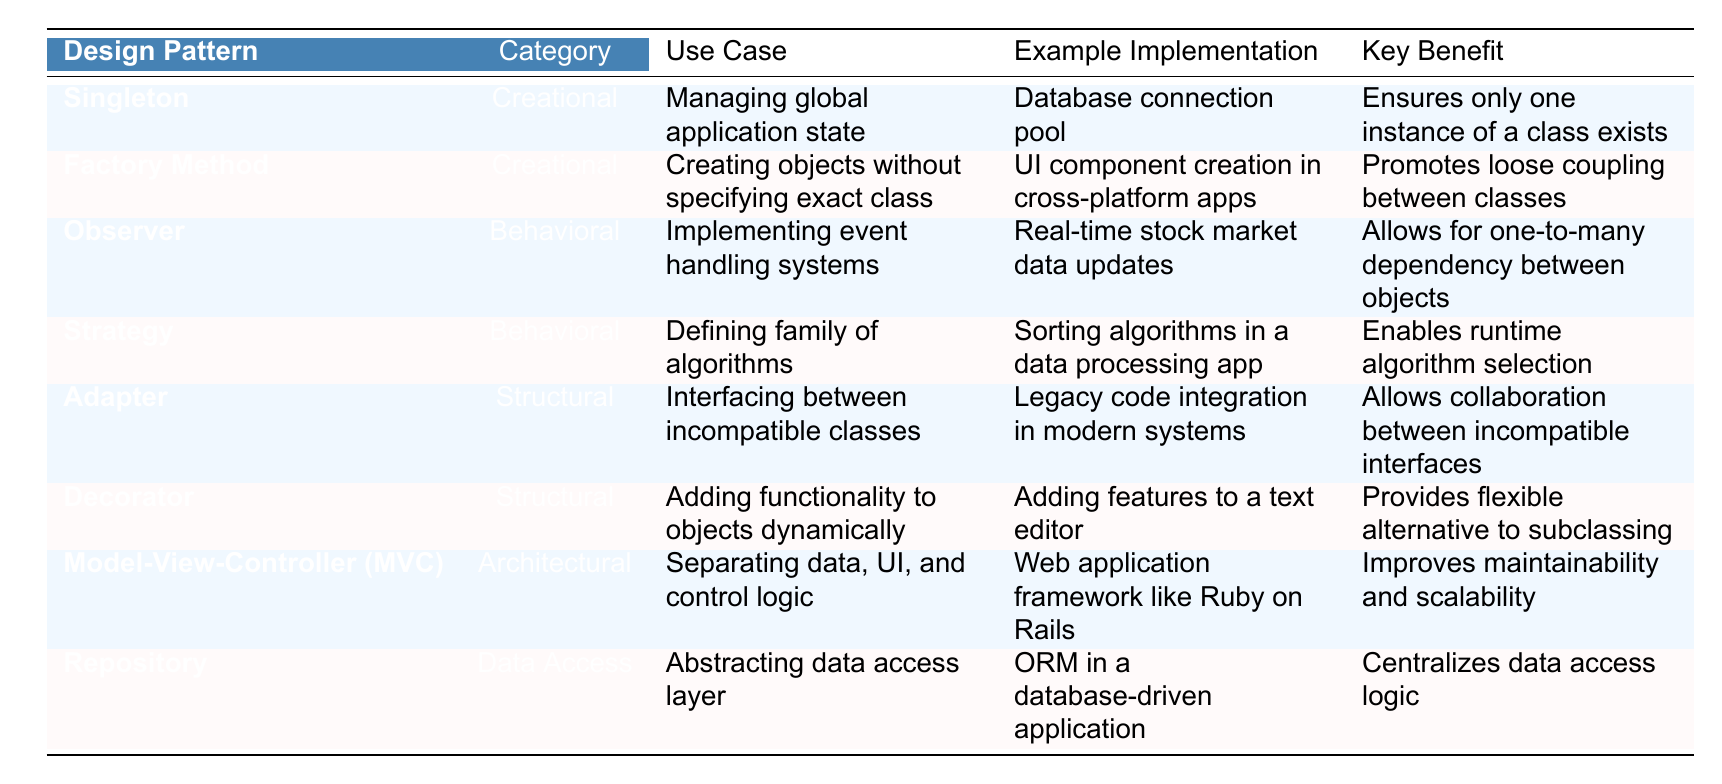What is the main category of the Singleton design pattern? According to the table, the Singleton design pattern falls under the "Creational" category.
Answer: Creational Which design pattern is used for real-time stock market data updates? The table indicates that the "Observer" design pattern is used for implementing event handling systems, specifically in the context of real-time stock market data updates.
Answer: Observer What key benefit is associated with the Factory Method design pattern? From the table, the key benefit of the Factory Method is that it promotes loose coupling between classes.
Answer: Promotes loose coupling Is the Adapter design pattern categorized as Behavioral? The table categorizes the Adapter design pattern as "Structural," indicating that it is not a Behavioral pattern.
Answer: No Which design pattern allows for one-to-many dependency between objects? The "Observer" design pattern enables one-to-many dependencies, as stated in the table.
Answer: Observer How many design patterns in the table are categorized as Data Access? The table lists only one design pattern under the Data Access category, which is the "Repository." Therefore, the count is one.
Answer: One What are the example implementations for the Decorator pattern and the Adapter pattern? The table shows that the Decorator pattern’s example implementation is "Adding features to a text editor," while the Adapter pattern is "Legacy code integration in modern systems."
Answer: Text editor features and Legacy code integration Which design pattern exists to improve maintainability and scalability? The Model-View-Controller (MVC) pattern is stated as improving maintainability and scalability in the table.
Answer: Model-View-Controller (MVC) If both Singleton and Factory Method patterns were to be used in an application, how would you describe their design categories? The Singleton pattern is in the Creational category and so is the Factory Method, meaning both share the same design category.
Answer: Both are Creational Which design patterns can be used to manage application state and object creation without specifying exact classes? The Singleton pattern manages global application state, while the Factory Method pattern creates objects without specifying exact classes, as indicated in the table.
Answer: Singleton and Factory Method 